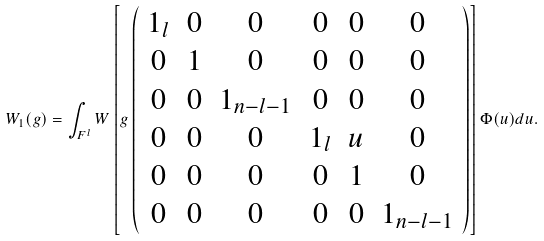Convert formula to latex. <formula><loc_0><loc_0><loc_500><loc_500>W _ { 1 } ( g ) = \int _ { F ^ { l } } W \left [ g \left ( \begin{array} { c c c c c c } 1 _ { l } & 0 & 0 & 0 & 0 & 0 \\ 0 & 1 & 0 & 0 & 0 & 0 \\ 0 & 0 & 1 _ { n - l - 1 } & 0 & 0 & 0 \\ 0 & 0 & 0 & 1 _ { l } & u & 0 \\ 0 & 0 & 0 & 0 & 1 & 0 \\ 0 & 0 & 0 & 0 & 0 & 1 _ { n - l - 1 } \end{array} \right ) \right ] \Phi ( u ) d u .</formula> 